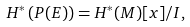<formula> <loc_0><loc_0><loc_500><loc_500>H ^ { * } \left ( P ( E ) \right ) = H ^ { * } ( M ) [ x ] / I ,</formula> 